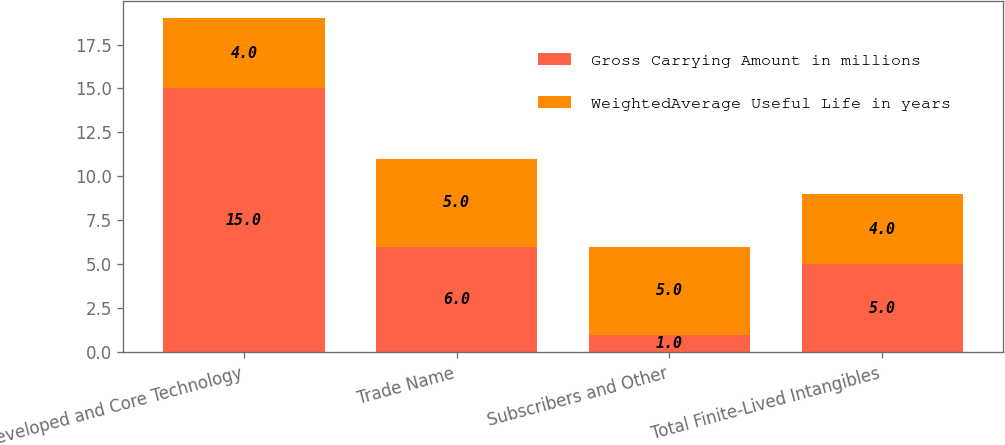Convert chart to OTSL. <chart><loc_0><loc_0><loc_500><loc_500><stacked_bar_chart><ecel><fcel>Developed and Core Technology<fcel>Trade Name<fcel>Subscribers and Other<fcel>Total Finite-Lived Intangibles<nl><fcel>Gross Carrying Amount in millions<fcel>15<fcel>6<fcel>1<fcel>5<nl><fcel>WeightedAverage Useful Life in years<fcel>4<fcel>5<fcel>5<fcel>4<nl></chart> 